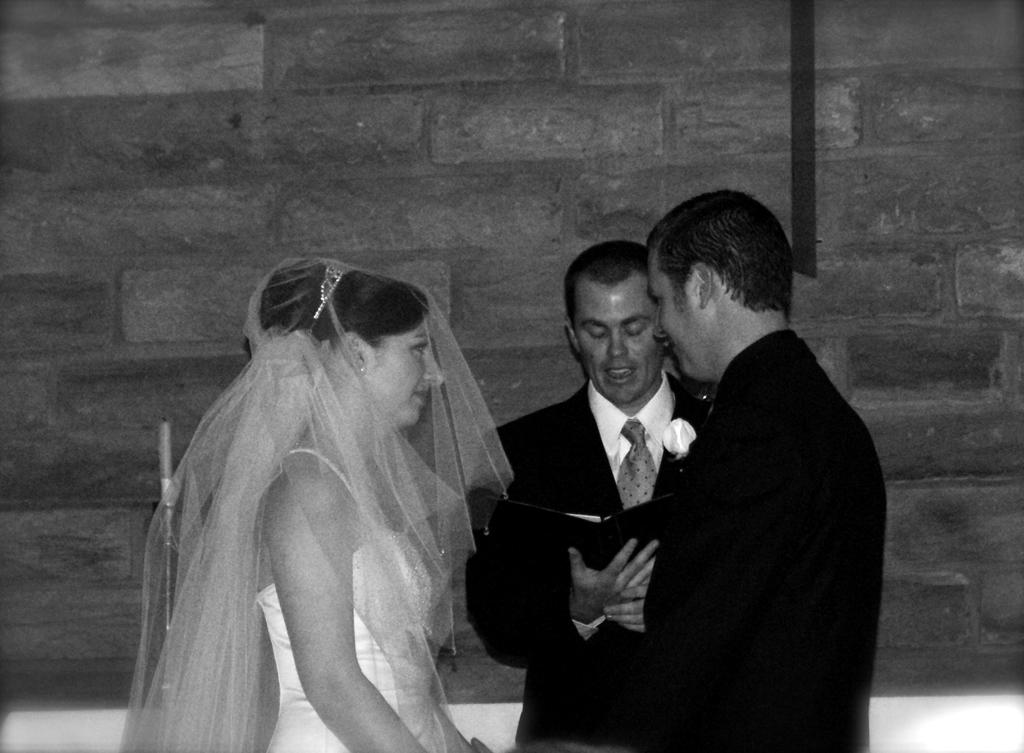What type of accessory is present in the image? There is a tie in the image. What object related to reading can be seen in the image? There is a book in the image. What type of lighting source is present in the image? There is a candle in the image. What symbol of authority is present in the image? There is a crown in the image. What type of clothing is present in the image? There are blazers in the image. How many people are present in the image? There are three people standing in the image. What can be seen in the background of the image? There is a wall visible in the background of the image. What type of farm animal can be seen in the image? There are no farm animals present in the image. What type of music-related item can be seen in the image? There are no music-related items, such as a record, present in the image. 